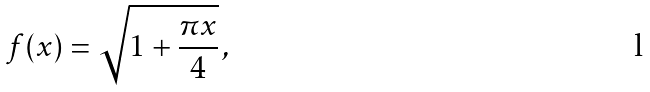Convert formula to latex. <formula><loc_0><loc_0><loc_500><loc_500>f ( x ) = \sqrt { 1 + \frac { \pi x } { 4 } } \, ,</formula> 